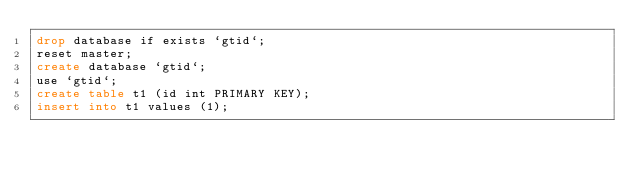<code> <loc_0><loc_0><loc_500><loc_500><_SQL_>drop database if exists `gtid`;
reset master;
create database `gtid`;
use `gtid`;
create table t1 (id int PRIMARY KEY);
insert into t1 values (1);</code> 